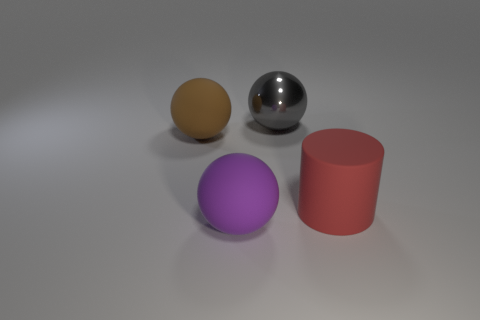Is the color of the big rubber thing right of the metallic object the same as the matte thing that is left of the big purple sphere?
Keep it short and to the point. No. The brown sphere has what size?
Your answer should be compact. Large. How many large objects are either red cylinders or rubber balls?
Give a very brief answer. 3. What is the color of the matte cylinder that is the same size as the purple rubber object?
Keep it short and to the point. Red. What number of other things are the same shape as the large red rubber object?
Your answer should be very brief. 0. Is there a big brown thing made of the same material as the big cylinder?
Give a very brief answer. Yes. Are the thing that is behind the brown thing and the ball that is on the left side of the large purple matte object made of the same material?
Offer a terse response. No. What number of matte spheres are there?
Your response must be concise. 2. What shape is the object that is behind the large brown ball?
Keep it short and to the point. Sphere. What number of other things are the same size as the cylinder?
Your response must be concise. 3. 